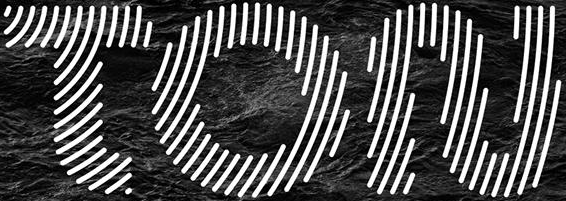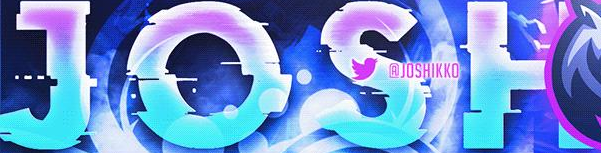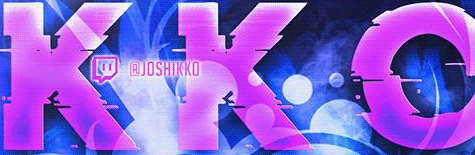Transcribe the words shown in these images in order, separated by a semicolon. TON; JOSH; KKO 